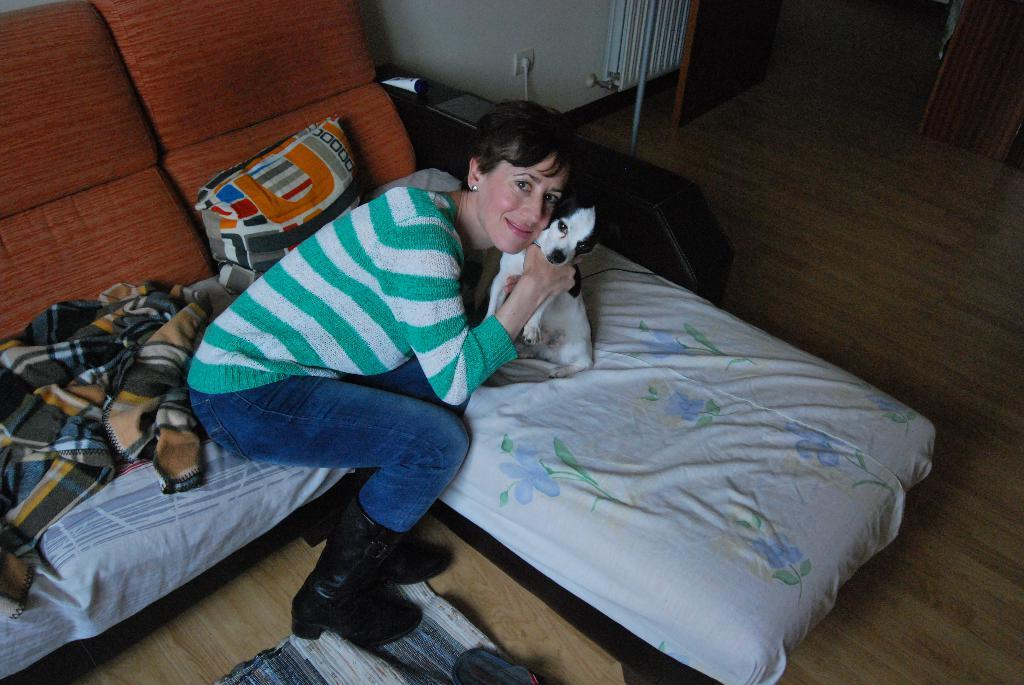Who is the main subject in the image? There is a woman in the image. What is the woman doing in the image? The woman is sitting on a couch and holding a dog. What is the woman's expression in the image? The woman is smiling in the image. What can be seen in the background of the image? There is a wall and a door in the background of the image. What type of group or selection is the woman a part of in the image? There is no indication in the image that the woman is part of a group or selection. Can you see any chains or chain-like objects in the image? There are no chains or chain-like objects visible in the image. 